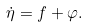Convert formula to latex. <formula><loc_0><loc_0><loc_500><loc_500>\dot { \eta } = f + \varphi .</formula> 